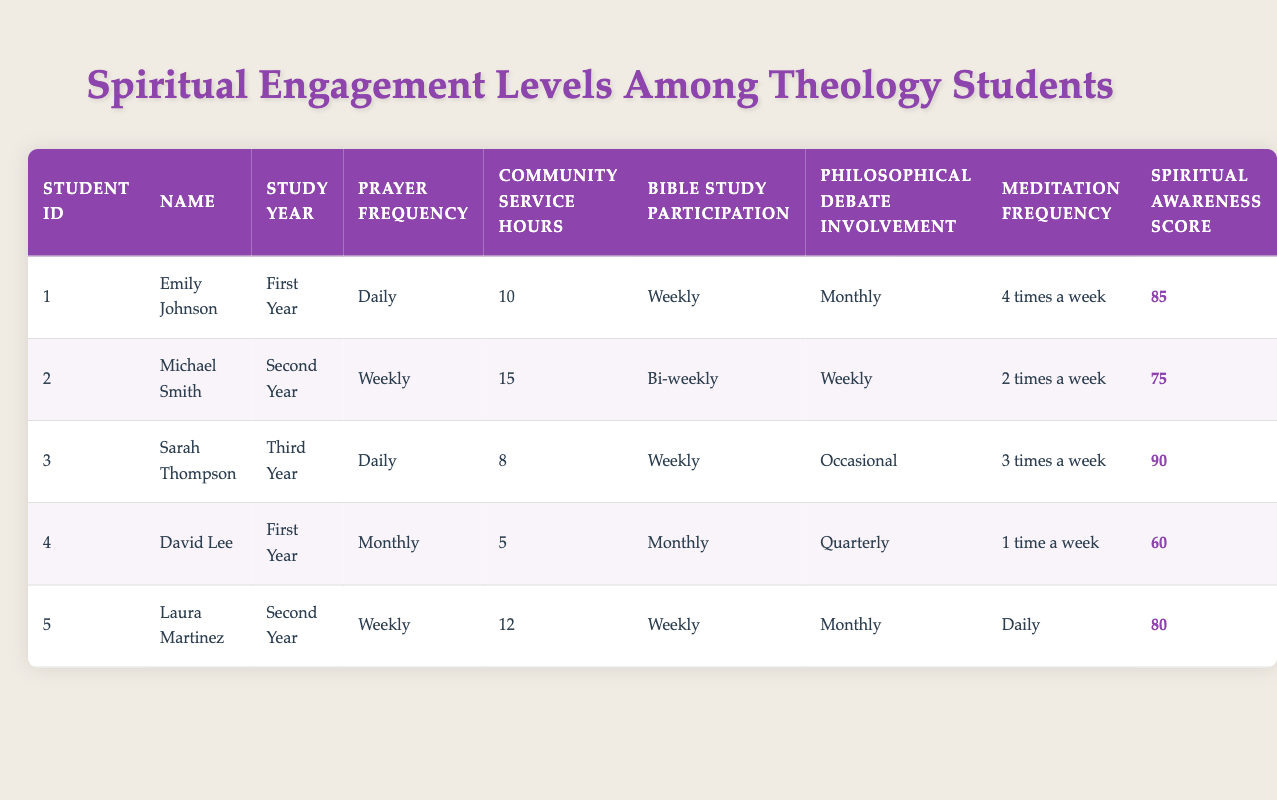What is the highest Spiritual Awareness Score among the students? Looking at the "Spiritual Awareness Score" column, the highest value is 90, which belongs to Sarah Thompson.
Answer: 90 Which student has the most Community Service Hours? In the "Community Service Hours" column, Michael Smith has the highest number with 15 hours.
Answer: Michael Smith How many students pray Daily? Only Emily Johnson and Sarah Thompson are listed as praying Daily. So, there are 2 students.
Answer: 2 What is the average Spiritual Awareness Score of students in their First Year? The students in their First Year are Emily Johnson and David Lee, with scores of 85 and 60 respectively. The average is (85 + 60) / 2 = 72.5.
Answer: 72.5 Is it true that all students in their Second Year participate in Bible Study Weekly? Michael Smith participates Bi-weekly in Bible Study, while Laura Martinez participates Weekly. This means not all Second Year students have Weekly participation.
Answer: No What is the difference in Community Service Hours between the student with the highest and the lowest score? The highest is Michael Smith with 15 hours and the lowest is David Lee with 5 hours. The difference is 15 - 5 = 10 hours.
Answer: 10 Which student has the highest frequency of Meditation, and how often do they meditate? By checking the "Meditation Frequency" column, Emily Johnson meditates 4 times a week, which is the highest frequency recorded.
Answer: Emily Johnson, 4 times a week How many students have Bible Study Participation at least Monthly? Emily Johnson and Sarah Thompson participate Weekly, David Lee participates Monthly, and Michael Smith participates Bi-weekly. Counting those, the total is 4.
Answer: 4 What is the pattern of Prayer Frequency among the three study years? The First Year students (Emily and David) have varied frequencies (Daily and Monthly), Second Year (Michael and Laura) are mostly Weekly, and the Third Year (Sarah) is Daily. This shows variability, with First Years showing less consistency.
Answer: Varied 